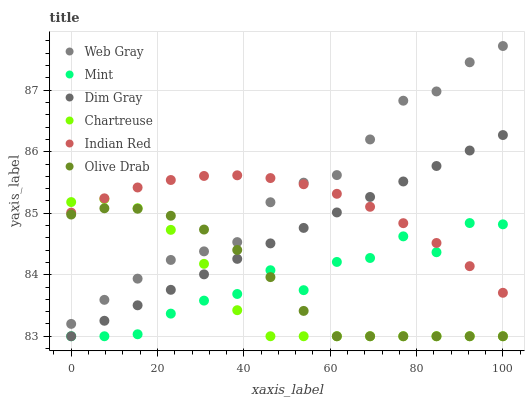Does Chartreuse have the minimum area under the curve?
Answer yes or no. Yes. Does Web Gray have the maximum area under the curve?
Answer yes or no. Yes. Does Web Gray have the minimum area under the curve?
Answer yes or no. No. Does Chartreuse have the maximum area under the curve?
Answer yes or no. No. Is Dim Gray the smoothest?
Answer yes or no. Yes. Is Mint the roughest?
Answer yes or no. Yes. Is Chartreuse the smoothest?
Answer yes or no. No. Is Chartreuse the roughest?
Answer yes or no. No. Does Dim Gray have the lowest value?
Answer yes or no. Yes. Does Web Gray have the lowest value?
Answer yes or no. No. Does Web Gray have the highest value?
Answer yes or no. Yes. Does Chartreuse have the highest value?
Answer yes or no. No. Is Mint less than Web Gray?
Answer yes or no. Yes. Is Indian Red greater than Olive Drab?
Answer yes or no. Yes. Does Dim Gray intersect Mint?
Answer yes or no. Yes. Is Dim Gray less than Mint?
Answer yes or no. No. Is Dim Gray greater than Mint?
Answer yes or no. No. Does Mint intersect Web Gray?
Answer yes or no. No. 